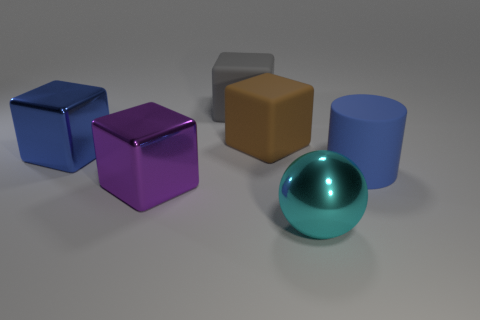Subtract all red cylinders. Subtract all brown cubes. How many cylinders are left? 1 Add 4 big blue cubes. How many objects exist? 10 Subtract all balls. How many objects are left? 5 Add 2 blue matte things. How many blue matte things are left? 3 Add 3 purple things. How many purple things exist? 4 Subtract 0 yellow cubes. How many objects are left? 6 Subtract all big brown shiny blocks. Subtract all big cylinders. How many objects are left? 5 